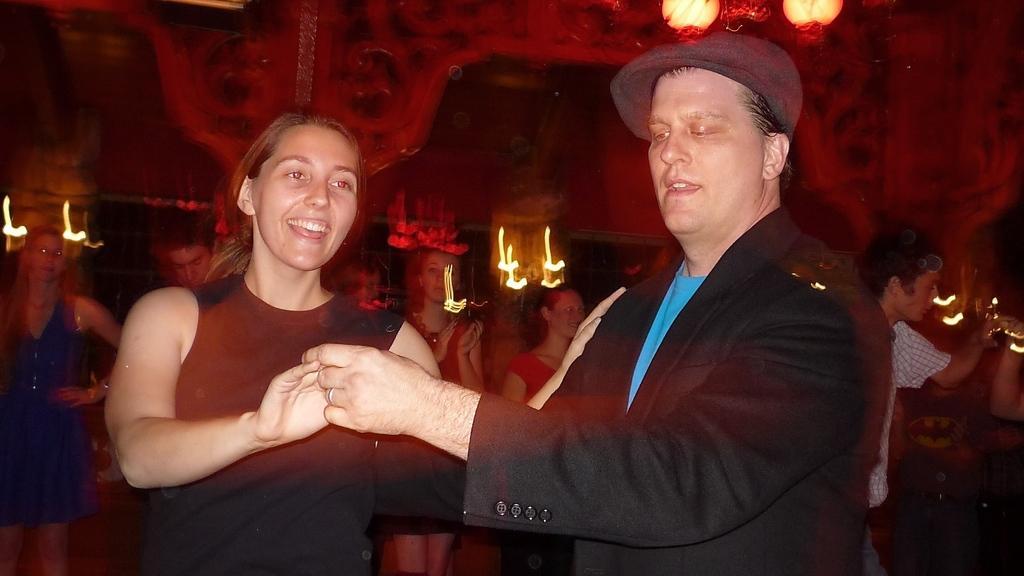Could you give a brief overview of what you see in this image? In this image, we can see a man and a woman standing, in the background we can see some people. 